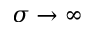<formula> <loc_0><loc_0><loc_500><loc_500>\sigma \to \infty</formula> 